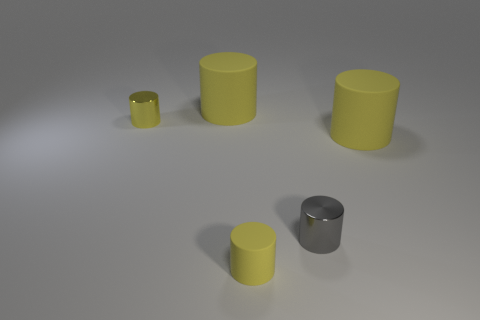Are there any tiny matte objects in front of the big matte thing right of the large yellow matte cylinder on the left side of the tiny rubber cylinder?
Keep it short and to the point. Yes. Is there any other thing that has the same shape as the gray metal object?
Your response must be concise. Yes. What is the material of the large yellow cylinder that is to the right of the big rubber thing that is left of the tiny matte cylinder?
Offer a very short reply. Rubber. There is a yellow cylinder on the right side of the gray metal cylinder; what is its size?
Offer a terse response. Large. There is a thing that is right of the yellow metallic cylinder and to the left of the tiny yellow rubber thing; what is its color?
Your response must be concise. Yellow. Does the yellow cylinder right of the gray thing have the same size as the tiny yellow rubber object?
Make the answer very short. No. Is there a tiny gray metal object that is right of the small matte object that is in front of the small gray metallic thing?
Offer a terse response. Yes. What is the small gray thing made of?
Give a very brief answer. Metal. There is a tiny gray shiny cylinder; are there any yellow cylinders behind it?
Give a very brief answer. Yes. What is the size of the other shiny thing that is the same shape as the gray metallic thing?
Keep it short and to the point. Small. 